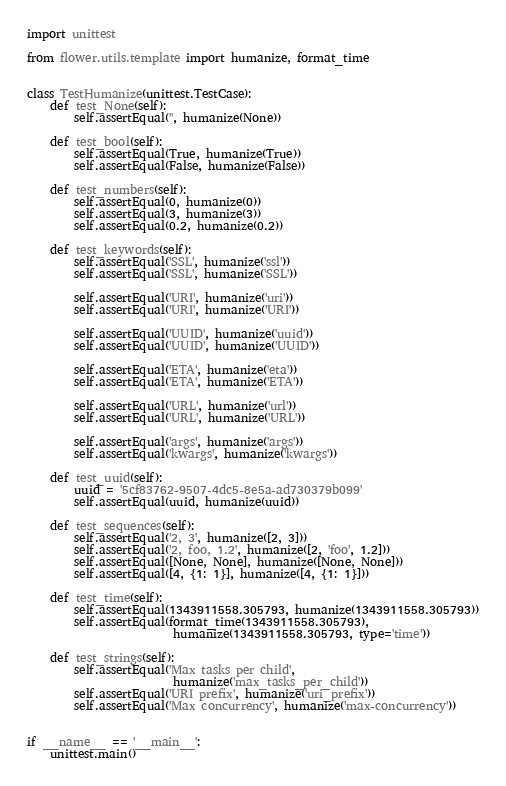<code> <loc_0><loc_0><loc_500><loc_500><_Python_>import unittest

from flower.utils.template import humanize, format_time


class TestHumanize(unittest.TestCase):
    def test_None(self):
        self.assertEqual('', humanize(None))

    def test_bool(self):
        self.assertEqual(True, humanize(True))
        self.assertEqual(False, humanize(False))

    def test_numbers(self):
        self.assertEqual(0, humanize(0))
        self.assertEqual(3, humanize(3))
        self.assertEqual(0.2, humanize(0.2))

    def test_keywords(self):
        self.assertEqual('SSL', humanize('ssl'))
        self.assertEqual('SSL', humanize('SSL'))

        self.assertEqual('URI', humanize('uri'))
        self.assertEqual('URI', humanize('URI'))

        self.assertEqual('UUID', humanize('uuid'))
        self.assertEqual('UUID', humanize('UUID'))

        self.assertEqual('ETA', humanize('eta'))
        self.assertEqual('ETA', humanize('ETA'))

        self.assertEqual('URL', humanize('url'))
        self.assertEqual('URL', humanize('URL'))

        self.assertEqual('args', humanize('args'))
        self.assertEqual('kwargs', humanize('kwargs'))

    def test_uuid(self):
        uuid = '5cf83762-9507-4dc5-8e5a-ad730379b099'
        self.assertEqual(uuid, humanize(uuid))

    def test_sequences(self):
        self.assertEqual('2, 3', humanize([2, 3]))
        self.assertEqual('2, foo, 1.2', humanize([2, 'foo', 1.2]))
        self.assertEqual([None, None], humanize([None, None]))
        self.assertEqual([4, {1: 1}], humanize([4, {1: 1}]))

    def test_time(self):
        self.assertEqual(1343911558.305793, humanize(1343911558.305793))
        self.assertEqual(format_time(1343911558.305793),
                         humanize(1343911558.305793, type='time'))

    def test_strings(self):
        self.assertEqual('Max tasks per child',
                         humanize('max_tasks_per_child'))
        self.assertEqual('URI prefix', humanize('uri_prefix'))
        self.assertEqual('Max concurrency', humanize('max-concurrency'))


if __name__ == '__main__':
    unittest.main()
</code> 